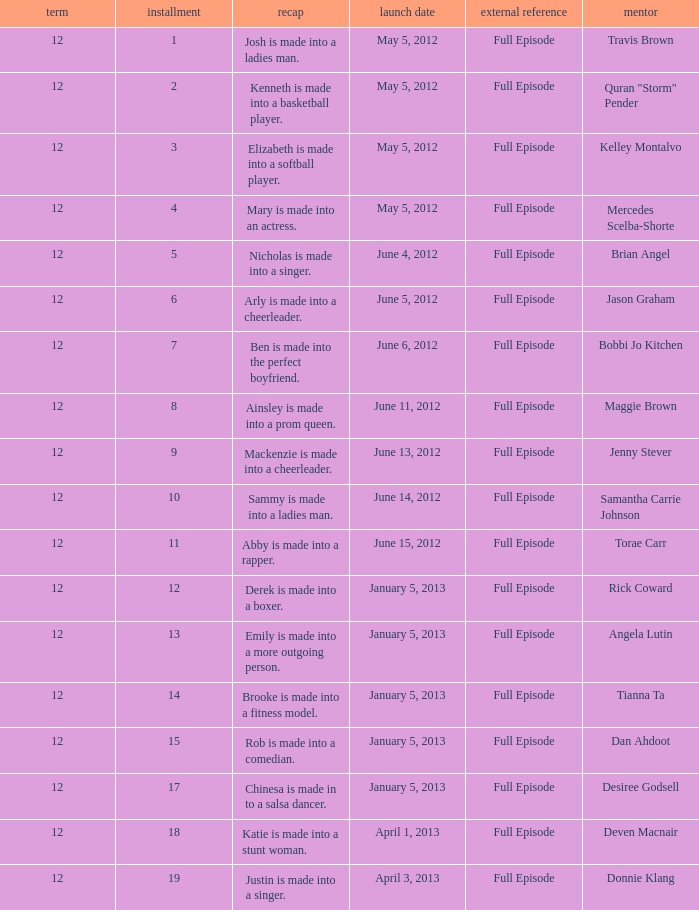Parse the full table. {'header': ['term', 'installment', 'recap', 'launch date', 'external reference', 'mentor'], 'rows': [['12', '1', 'Josh is made into a ladies man.', 'May 5, 2012', 'Full Episode', 'Travis Brown'], ['12', '2', 'Kenneth is made into a basketball player.', 'May 5, 2012', 'Full Episode', 'Quran "Storm" Pender'], ['12', '3', 'Elizabeth is made into a softball player.', 'May 5, 2012', 'Full Episode', 'Kelley Montalvo'], ['12', '4', 'Mary is made into an actress.', 'May 5, 2012', 'Full Episode', 'Mercedes Scelba-Shorte'], ['12', '5', 'Nicholas is made into a singer.', 'June 4, 2012', 'Full Episode', 'Brian Angel'], ['12', '6', 'Arly is made into a cheerleader.', 'June 5, 2012', 'Full Episode', 'Jason Graham'], ['12', '7', 'Ben is made into the perfect boyfriend.', 'June 6, 2012', 'Full Episode', 'Bobbi Jo Kitchen'], ['12', '8', 'Ainsley is made into a prom queen.', 'June 11, 2012', 'Full Episode', 'Maggie Brown'], ['12', '9', 'Mackenzie is made into a cheerleader.', 'June 13, 2012', 'Full Episode', 'Jenny Stever'], ['12', '10', 'Sammy is made into a ladies man.', 'June 14, 2012', 'Full Episode', 'Samantha Carrie Johnson'], ['12', '11', 'Abby is made into a rapper.', 'June 15, 2012', 'Full Episode', 'Torae Carr'], ['12', '12', 'Derek is made into a boxer.', 'January 5, 2013', 'Full Episode', 'Rick Coward'], ['12', '13', 'Emily is made into a more outgoing person.', 'January 5, 2013', 'Full Episode', 'Angela Lutin'], ['12', '14', 'Brooke is made into a fitness model.', 'January 5, 2013', 'Full Episode', 'Tianna Ta'], ['12', '15', 'Rob is made into a comedian.', 'January 5, 2013', 'Full Episode', 'Dan Ahdoot'], ['12', '17', 'Chinesa is made in to a salsa dancer.', 'January 5, 2013', 'Full Episode', 'Desiree Godsell'], ['12', '18', 'Katie is made into a stunt woman.', 'April 1, 2013', 'Full Episode', 'Deven Macnair'], ['12', '19', 'Justin is made into a singer.', 'April 3, 2013', 'Full Episode', 'Donnie Klang']]} Name the episode summary for torae carr Abby is made into a rapper. 